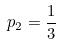<formula> <loc_0><loc_0><loc_500><loc_500>p _ { 2 } = \frac { 1 } { 3 }</formula> 